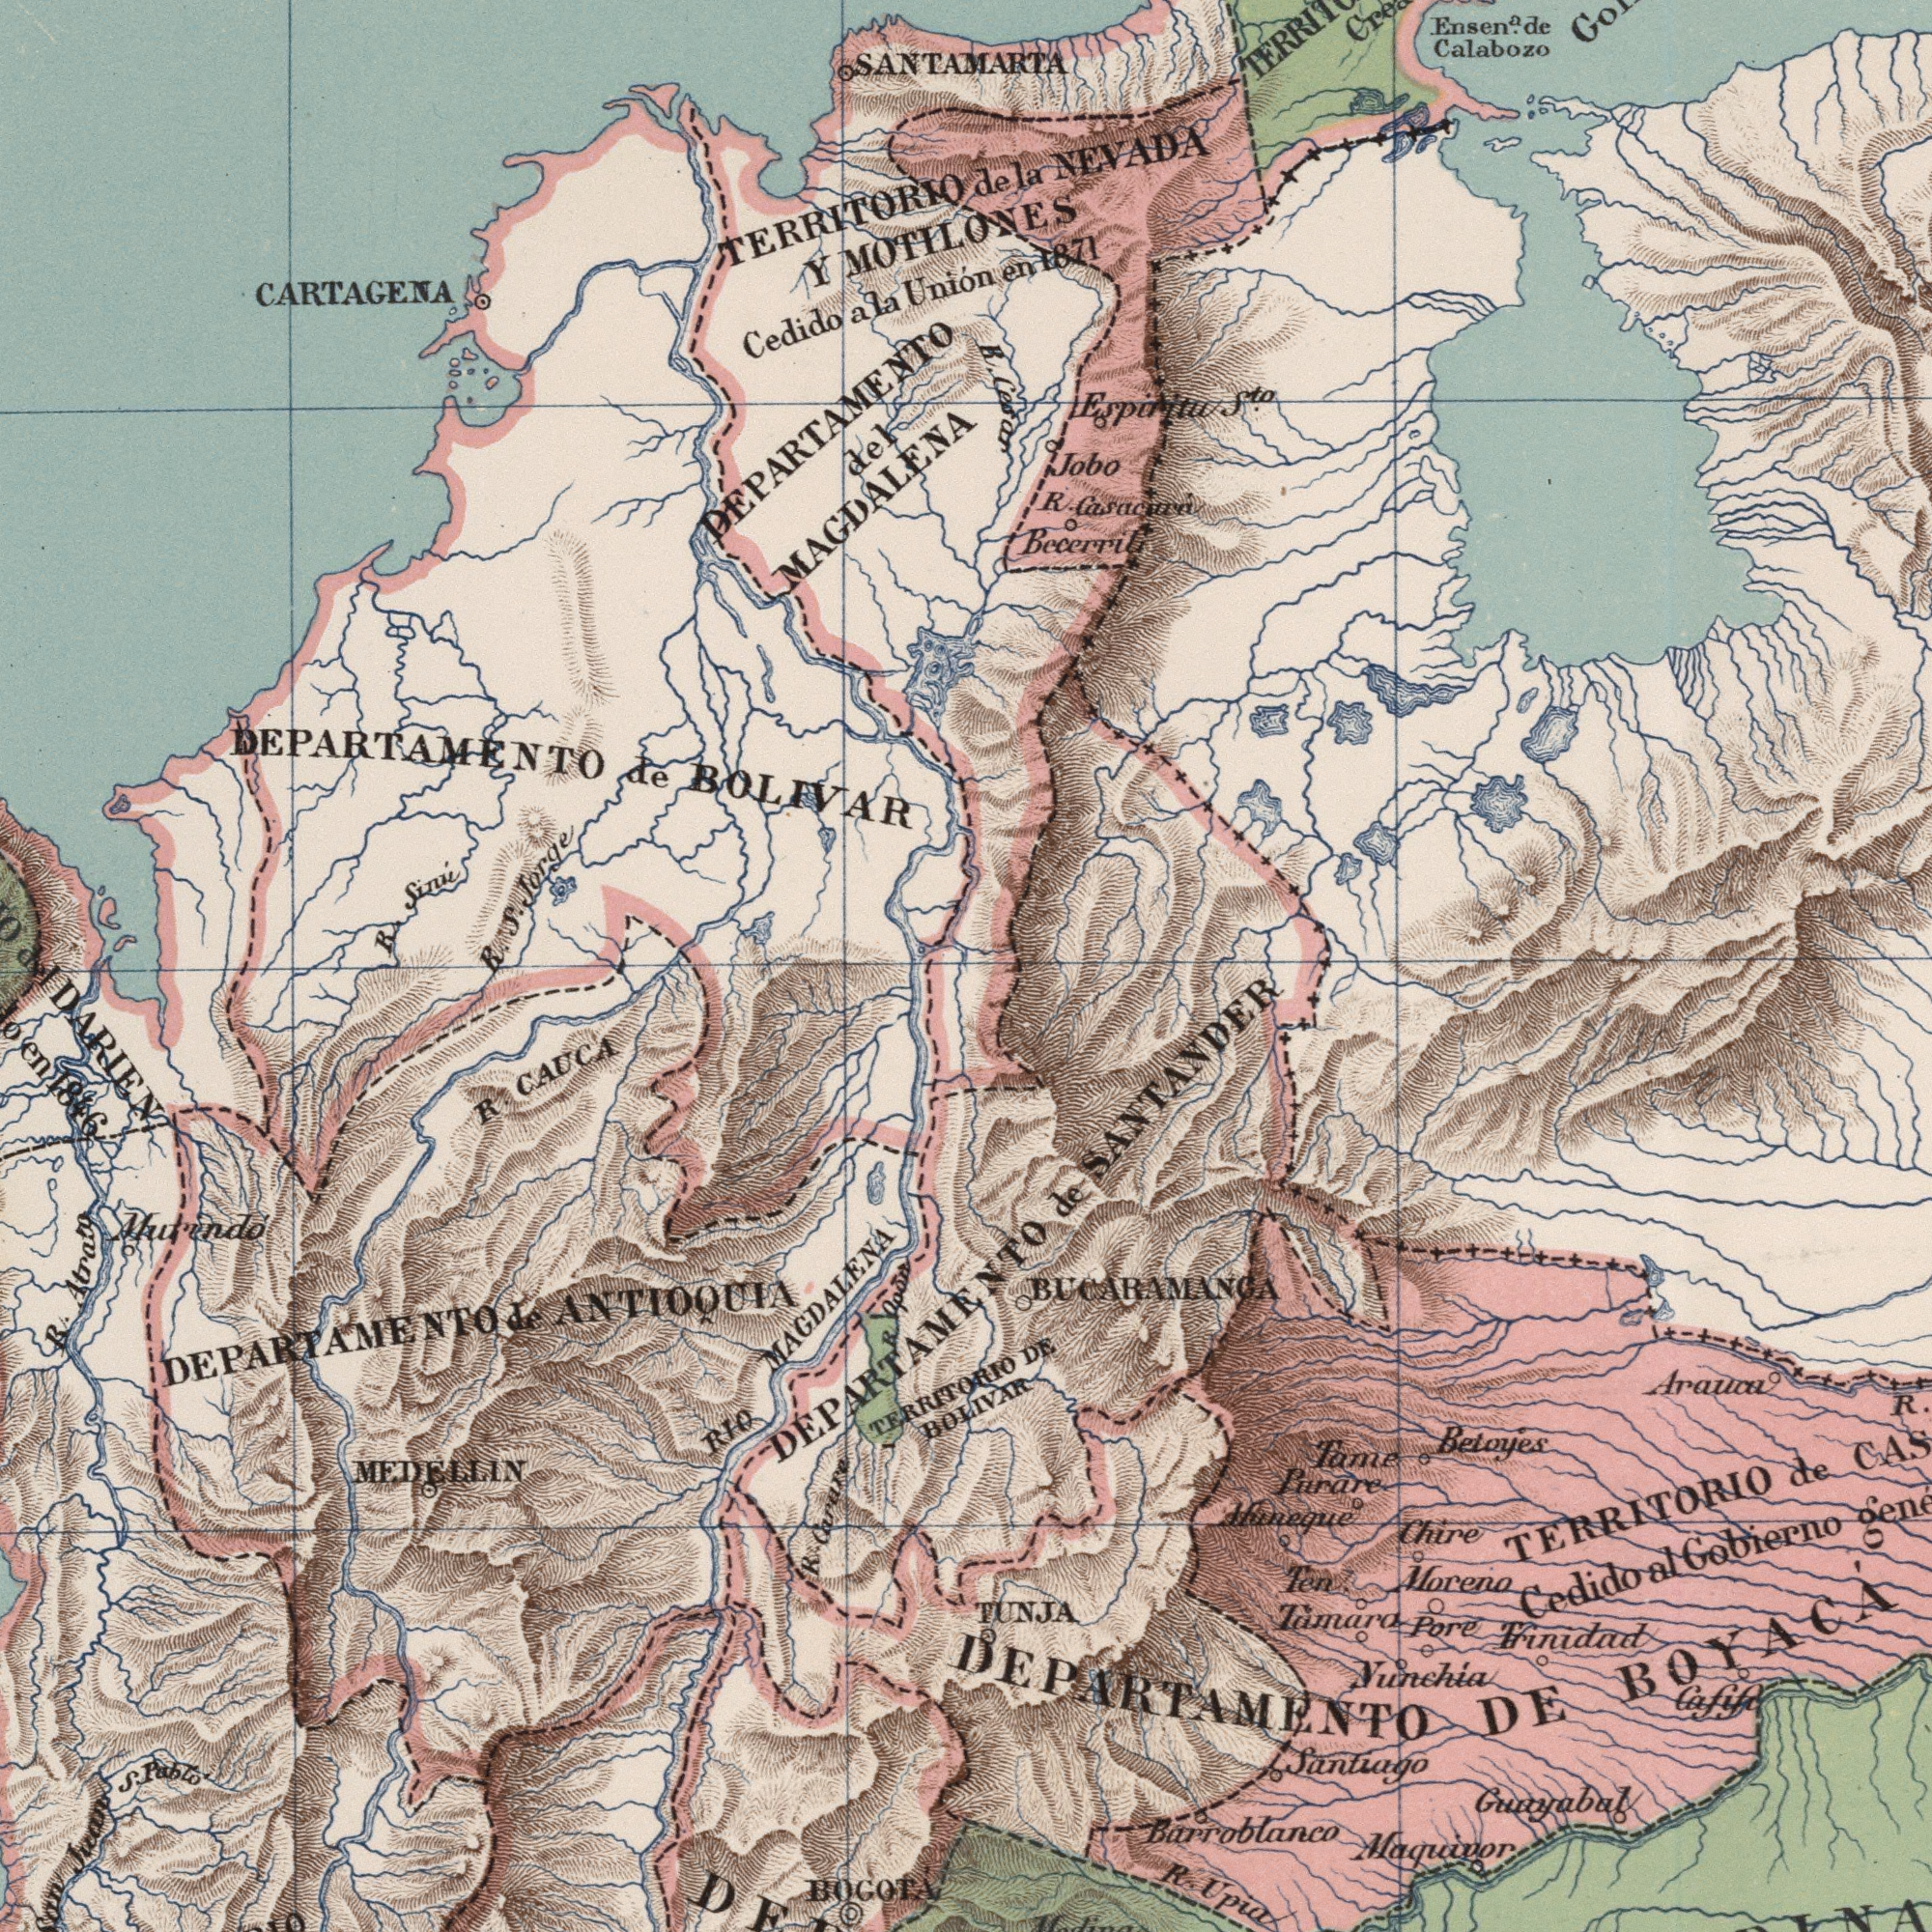What text can you see in the bottom-left section? Murindó BOGOTÁ ANTIOQUIA MEDELLIN IDARIEN CAUCA MAGDALENA R. Carare Juan TERRITORIO Pablo DEPARTAMENTO RIO DEPARTAMENTO S. R. R. R. 1846 de What text appears in the top-left area of the image? BOLIVAR MOTILONES SANTAMARTA Y Sinu Cedidoala Uniónen del CARTAGENA R. DEPARTAMENTO Jorge S. de MAGDALENA TERRITORIO DEPARTAMENTO R. de Cedidoala Cedidoala What text is visible in the lower-right corner? Maquivor Guayabal Barroblanco Nunchia Santiago Betoyes Trinidad Tamaro TUNJA Moreno Purare DE Chire Gobierno de Arauca BUCARAMANGA TERRITORIO BELIVAR SANTANDER Tame Cafif Pore R. R. DEPARTAMENTO DE ###neque BOYACÁ de Cedidoal Ten What text is shown in the top-right quadrant? NEVADA Calabozo Espiritu Jobo R. Ensen. Becerril R. de 1871 S<sup>to</sup>. de la Uniónen 